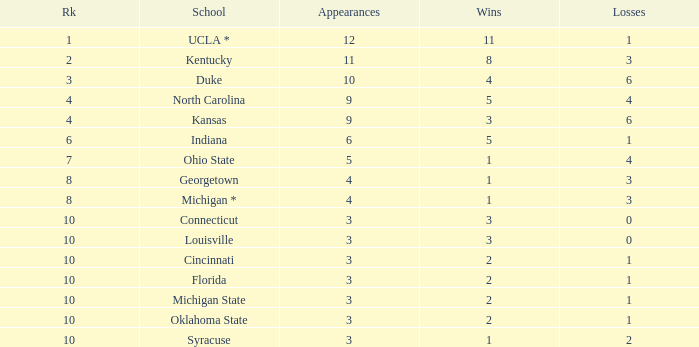Tell me the sum of losses for wins less than 2 and rank of 10 with appearances larger than 3 None. 